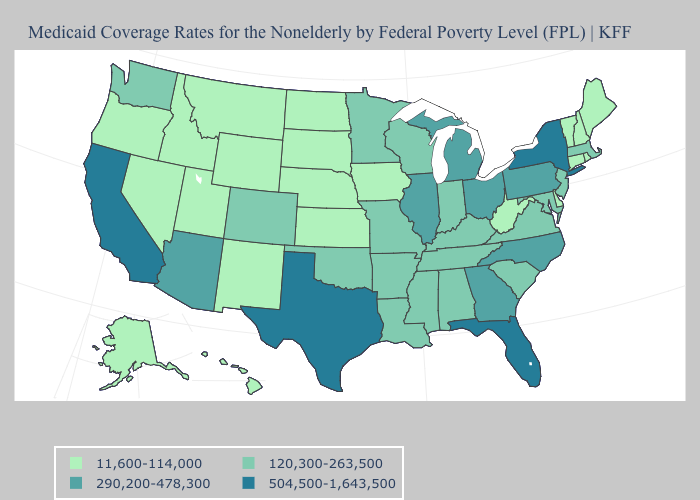Is the legend a continuous bar?
Give a very brief answer. No. Name the states that have a value in the range 120,300-263,500?
Quick response, please. Alabama, Arkansas, Colorado, Indiana, Kentucky, Louisiana, Maryland, Massachusetts, Minnesota, Mississippi, Missouri, New Jersey, Oklahoma, South Carolina, Tennessee, Virginia, Washington, Wisconsin. What is the value of Kansas?
Concise answer only. 11,600-114,000. Which states have the lowest value in the USA?
Write a very short answer. Alaska, Connecticut, Delaware, Hawaii, Idaho, Iowa, Kansas, Maine, Montana, Nebraska, Nevada, New Hampshire, New Mexico, North Dakota, Oregon, Rhode Island, South Dakota, Utah, Vermont, West Virginia, Wyoming. Does Washington have a higher value than Idaho?
Answer briefly. Yes. What is the value of South Dakota?
Give a very brief answer. 11,600-114,000. Which states have the lowest value in the USA?
Write a very short answer. Alaska, Connecticut, Delaware, Hawaii, Idaho, Iowa, Kansas, Maine, Montana, Nebraska, Nevada, New Hampshire, New Mexico, North Dakota, Oregon, Rhode Island, South Dakota, Utah, Vermont, West Virginia, Wyoming. Does the first symbol in the legend represent the smallest category?
Short answer required. Yes. Which states hav the highest value in the Northeast?
Concise answer only. New York. What is the value of Wyoming?
Answer briefly. 11,600-114,000. Name the states that have a value in the range 504,500-1,643,500?
Be succinct. California, Florida, New York, Texas. Does the first symbol in the legend represent the smallest category?
Answer briefly. Yes. Name the states that have a value in the range 504,500-1,643,500?
Be succinct. California, Florida, New York, Texas. Does Idaho have the same value as Vermont?
Keep it brief. Yes. What is the lowest value in states that border Oregon?
Give a very brief answer. 11,600-114,000. 